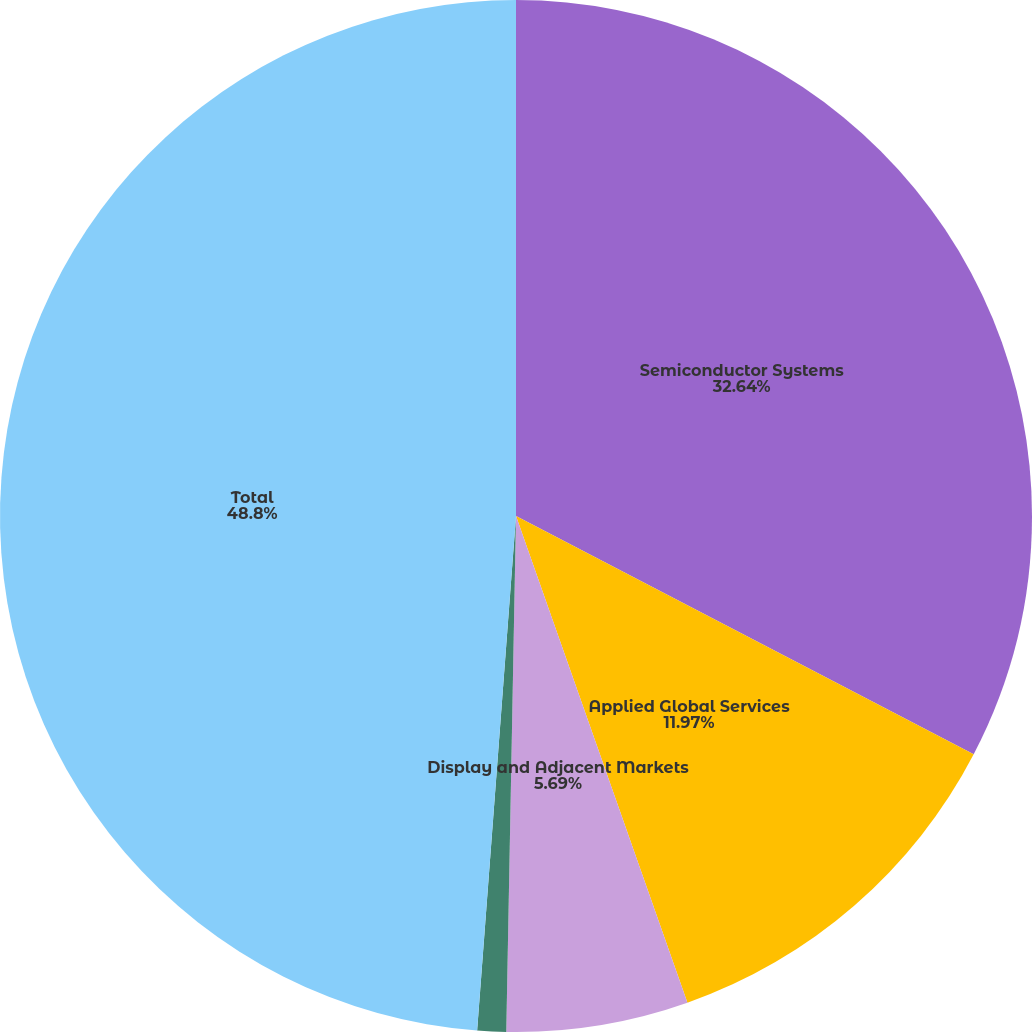Convert chart. <chart><loc_0><loc_0><loc_500><loc_500><pie_chart><fcel>Semiconductor Systems<fcel>Applied Global Services<fcel>Display and Adjacent Markets<fcel>Corporate and Other<fcel>Total<nl><fcel>32.64%<fcel>11.97%<fcel>5.69%<fcel>0.9%<fcel>48.8%<nl></chart> 